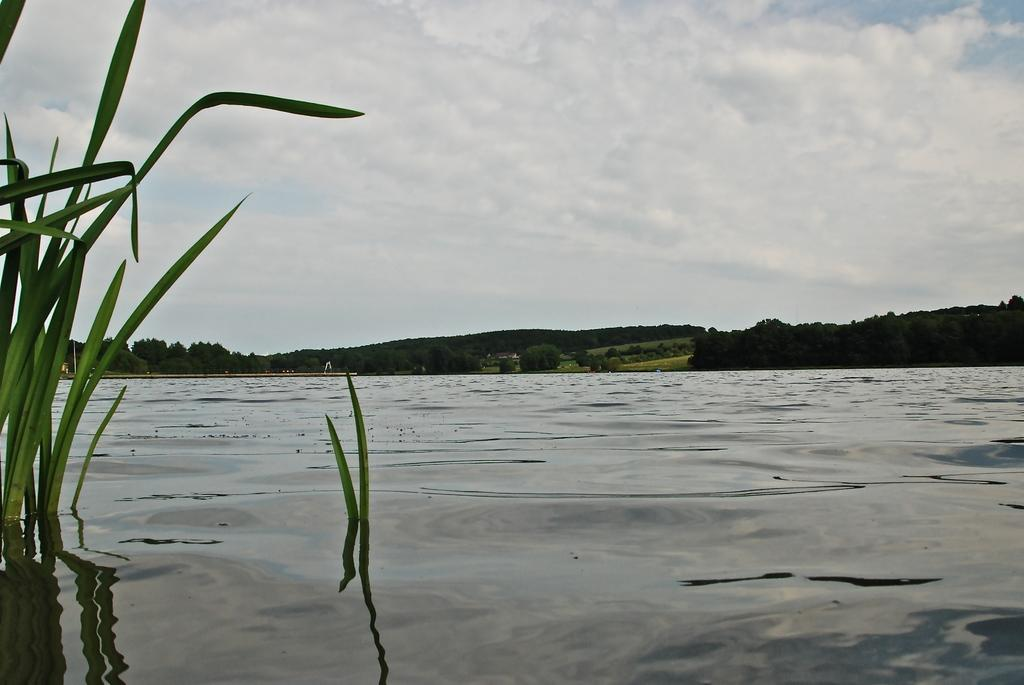What type of vegetation is visible in the image? There is grass in the image. What natural element is also present in the image? There is water in the image. What can be seen in the background of the image? There are trees, a pole, and grass in the background of the image. What is visible in the sky in the background of the image? The sky is visible in the background of the image, and clouds are present. What type of breakfast is being served in the image? There is no breakfast present in the image; it features grass, water, trees, a pole, and clouds. 